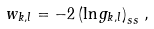Convert formula to latex. <formula><loc_0><loc_0><loc_500><loc_500>w _ { k , l } = - 2 \left ( \ln { g _ { k , l } } \right ) _ { s s } \, ,</formula> 